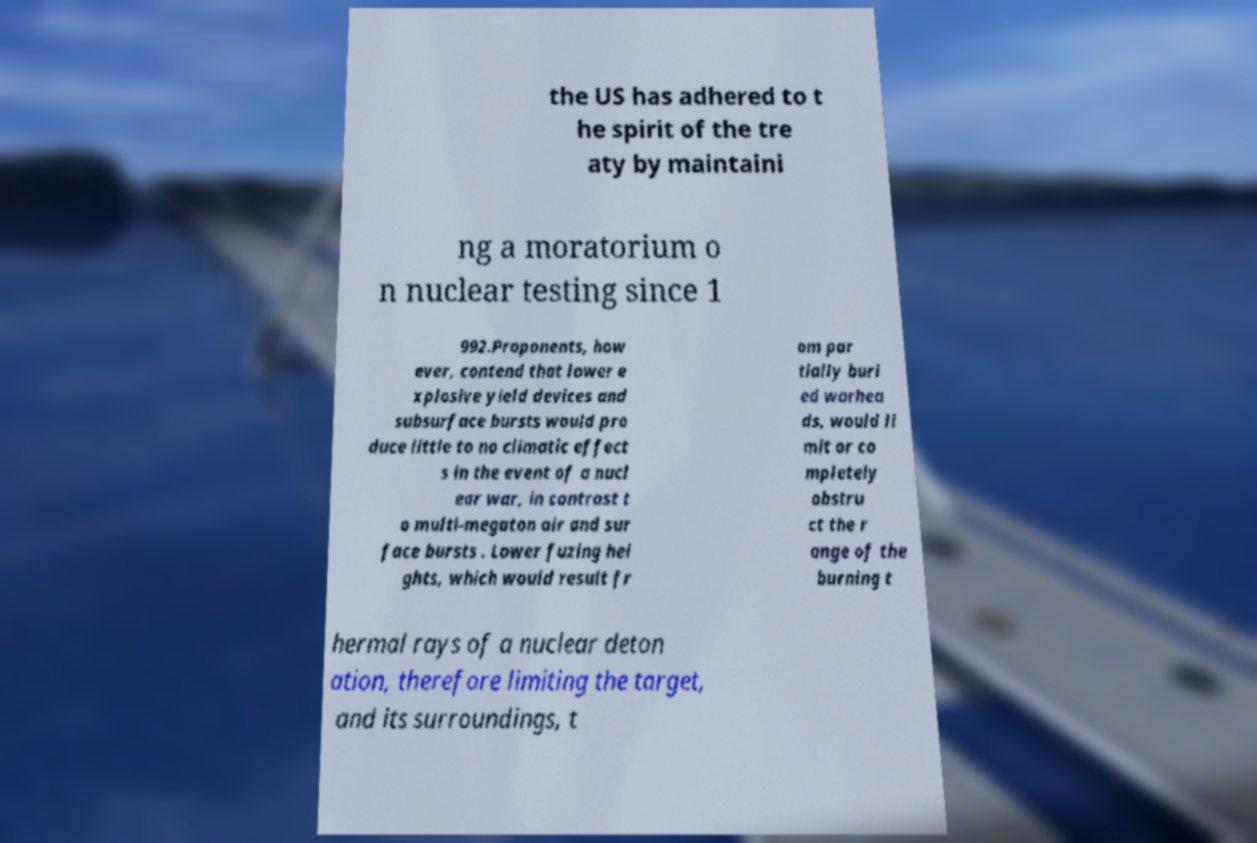For documentation purposes, I need the text within this image transcribed. Could you provide that? the US has adhered to t he spirit of the tre aty by maintaini ng a moratorium o n nuclear testing since 1 992.Proponents, how ever, contend that lower e xplosive yield devices and subsurface bursts would pro duce little to no climatic effect s in the event of a nucl ear war, in contrast t o multi-megaton air and sur face bursts . Lower fuzing hei ghts, which would result fr om par tially buri ed warhea ds, would li mit or co mpletely obstru ct the r ange of the burning t hermal rays of a nuclear deton ation, therefore limiting the target, and its surroundings, t 